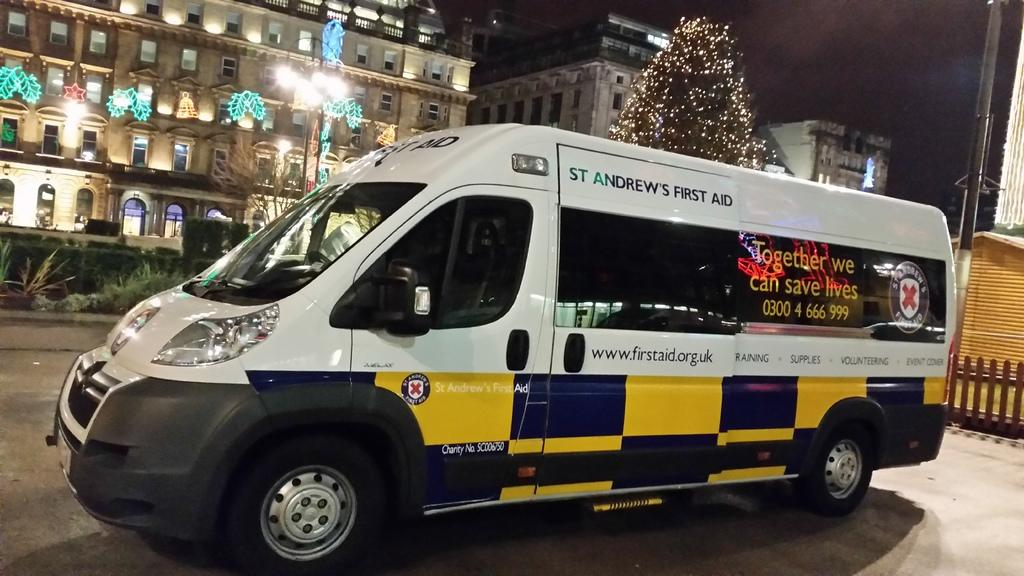<image>
Offer a succinct explanation of the picture presented. White van which says First Aid on it. 